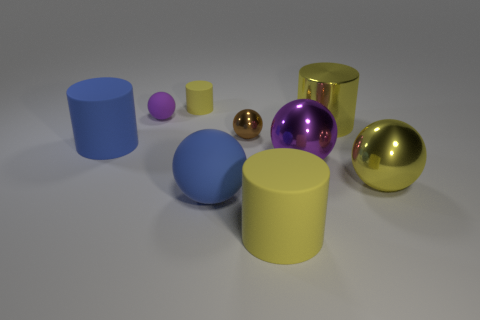If these objects were to be part of a larger scene, what context could they belong to? These objects could belong to a variety of contexts. For instance, they might be part of a still life composition in an artist's study, serving to study geometry, reflections, and shading. Alternatively, they could represent a product display for a designer showcasing prototypes of homeware goods or a simulated scenario for a 3D modeling tutorial focusing on material properties and lighting effects. 